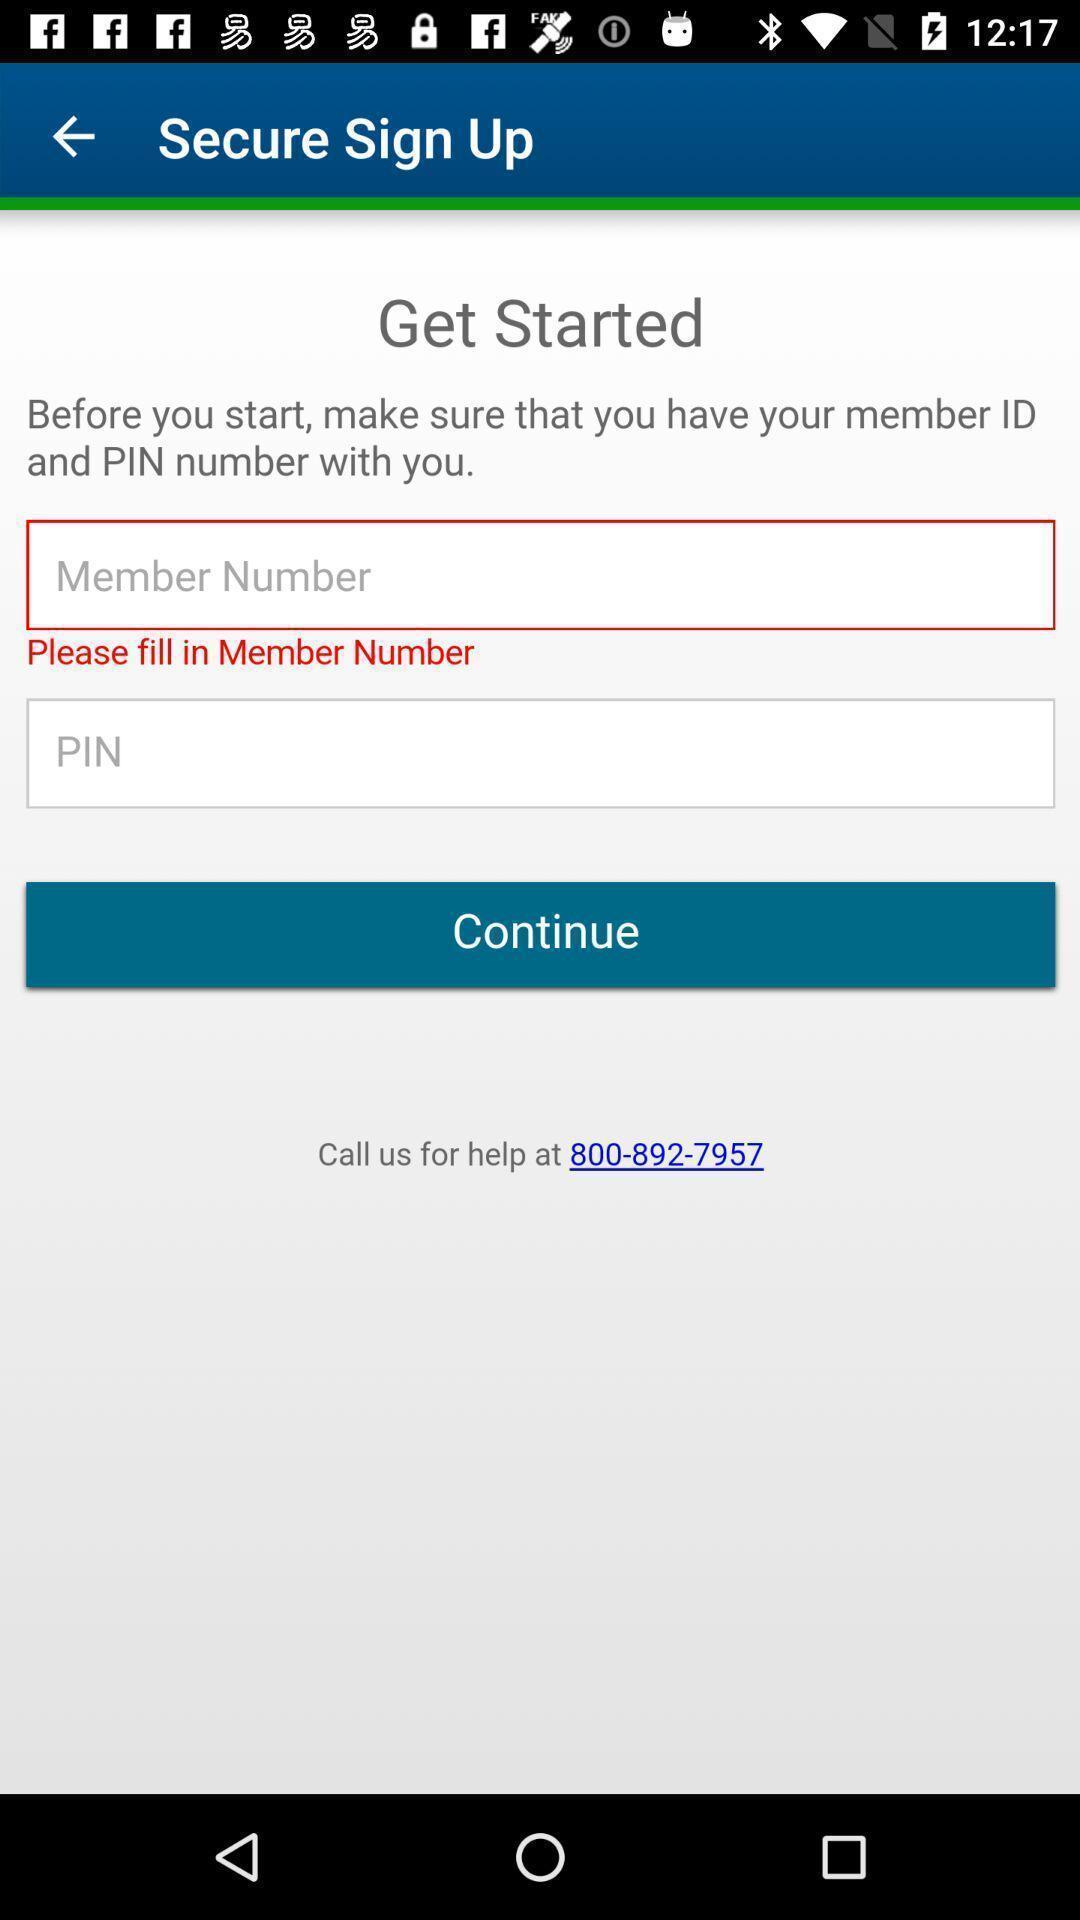Provide a textual representation of this image. Sign up page. 